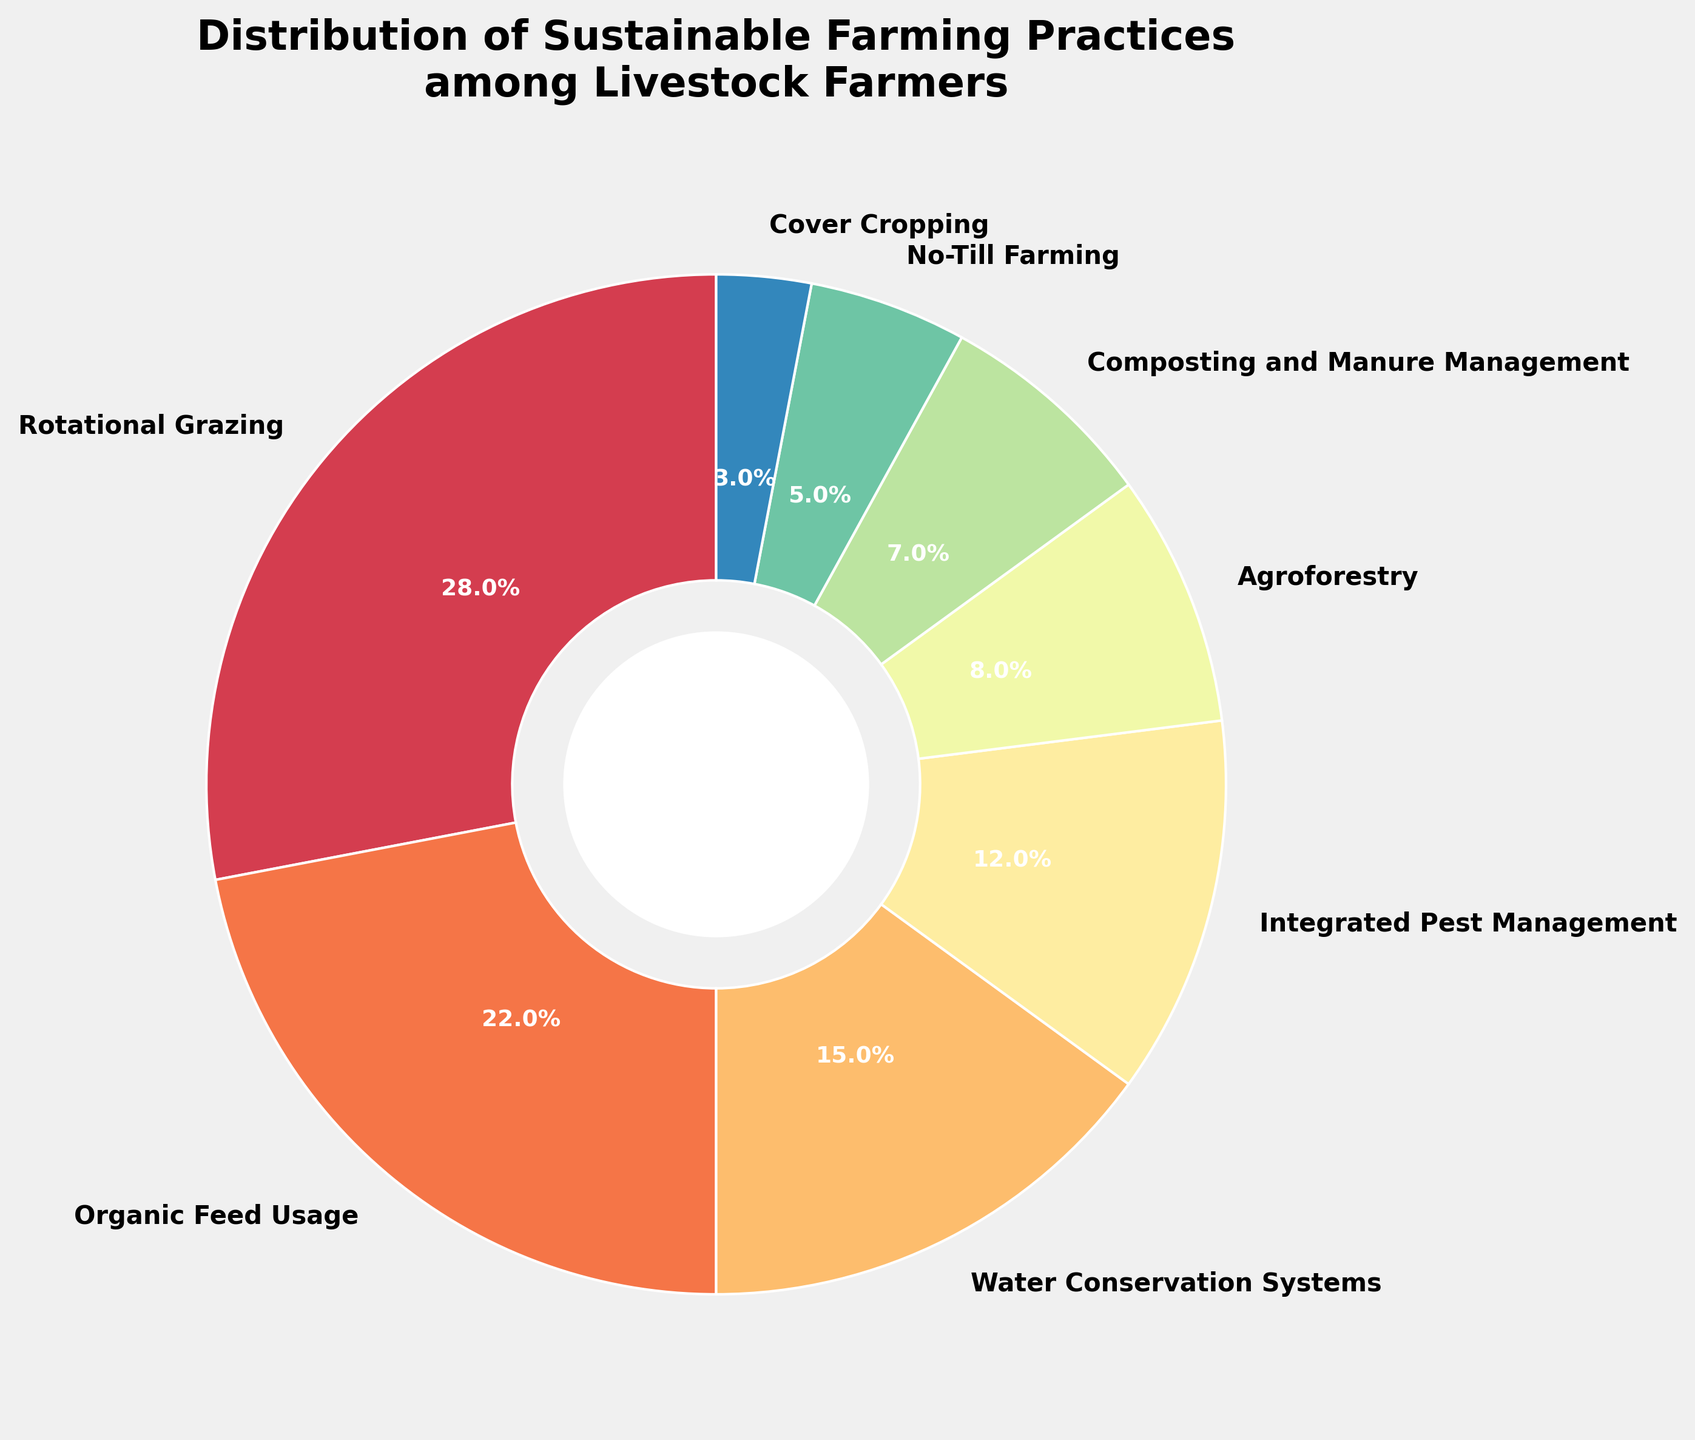How many sustainable farming practices are shown in the pie chart? The pie chart presents 8 distinct sustainable farming practices, as indicated by the 8 segments.
Answer: 8 Which sustainable farming practice has the highest percentage? From the pie chart, 'Rotational Grazing' has the largest segment, representing 28%.
Answer: Rotational Grazing Which two practices together represent less than 10%? Observing the smaller segments, 'No-Till Farming' at 5% and 'Cover Cropping' at 3% together sum to 8%, which is less than 10%.
Answer: No-Till Farming and Cover Cropping What is the percentage difference between 'Organic Feed Usage' and 'Agroforestry'? 'Organic Feed Usage' has 22% and 'Agroforestry' has 8%. The percentage difference is 22% - 8% = 14%.
Answer: 14% Which practice categories could be described as having the middle range percentages? 'Water Conservation Systems' at 15% and 'Integrated Pest Management' at 12% are near the median, making them middle-range categories.
Answer: Water Conservation Systems and Integrated Pest Management Is 'Composting and Manure Management' more or less common than 'Agroforestry'? 'Composting and Manure Management' has 7%, and 'Agroforestry' has 8%, showing that the former is less common.
Answer: Less Calculate the combined percentage of 'Organic Feed Usage' and 'Water Conservation Systems'. Adding the percentages for 'Organic Feed Usage' (22%) and 'Water Conservation Systems' (15%), we get 22% + 15% = 37%.
Answer: 37% Which practice constitutes slightly more than one-quarter of the depicted practices? 'Rotational Grazing' constitutes 28%, which is slightly more than one-quarter (25%).
Answer: Rotational Grazing Which practice has the smallest segment in the pie chart? The smallest segment, as seen in the pie chart, represents 'Cover Cropping' with 3%.
Answer: Cover Cropping How do 'No-Till Farming' and 'Composting and Manure Management' compare visually in terms of color? 'No-Till Farming' and 'Composting and Manure Management' segments appear in adjacent shades, indicating proximity in their color representation in the chart.
Answer: Adjacent shades 